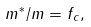<formula> <loc_0><loc_0><loc_500><loc_500>m ^ { * } / m = f _ { c } ,</formula> 